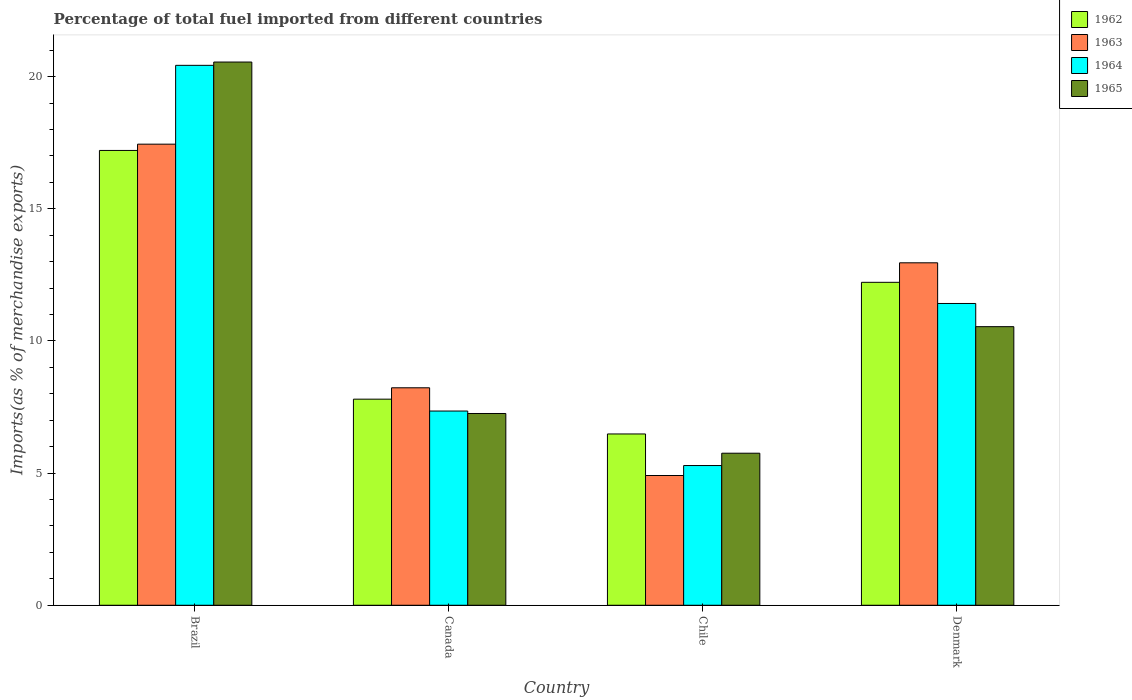How many different coloured bars are there?
Keep it short and to the point. 4. How many groups of bars are there?
Ensure brevity in your answer.  4. Are the number of bars per tick equal to the number of legend labels?
Keep it short and to the point. Yes. Are the number of bars on each tick of the X-axis equal?
Make the answer very short. Yes. How many bars are there on the 4th tick from the right?
Offer a terse response. 4. What is the percentage of imports to different countries in 1962 in Denmark?
Offer a very short reply. 12.22. Across all countries, what is the maximum percentage of imports to different countries in 1965?
Provide a succinct answer. 20.55. Across all countries, what is the minimum percentage of imports to different countries in 1964?
Keep it short and to the point. 5.29. In which country was the percentage of imports to different countries in 1964 maximum?
Your answer should be compact. Brazil. In which country was the percentage of imports to different countries in 1963 minimum?
Ensure brevity in your answer.  Chile. What is the total percentage of imports to different countries in 1965 in the graph?
Your answer should be compact. 44.11. What is the difference between the percentage of imports to different countries in 1965 in Canada and that in Denmark?
Provide a succinct answer. -3.29. What is the difference between the percentage of imports to different countries in 1963 in Chile and the percentage of imports to different countries in 1964 in Denmark?
Give a very brief answer. -6.51. What is the average percentage of imports to different countries in 1965 per country?
Offer a very short reply. 11.03. What is the difference between the percentage of imports to different countries of/in 1965 and percentage of imports to different countries of/in 1962 in Chile?
Provide a short and direct response. -0.73. What is the ratio of the percentage of imports to different countries in 1962 in Canada to that in Denmark?
Provide a short and direct response. 0.64. Is the difference between the percentage of imports to different countries in 1965 in Brazil and Canada greater than the difference between the percentage of imports to different countries in 1962 in Brazil and Canada?
Provide a succinct answer. Yes. What is the difference between the highest and the second highest percentage of imports to different countries in 1963?
Your answer should be compact. -9.22. What is the difference between the highest and the lowest percentage of imports to different countries in 1962?
Your answer should be very brief. 10.73. In how many countries, is the percentage of imports to different countries in 1962 greater than the average percentage of imports to different countries in 1962 taken over all countries?
Provide a succinct answer. 2. Is the sum of the percentage of imports to different countries in 1964 in Brazil and Denmark greater than the maximum percentage of imports to different countries in 1963 across all countries?
Ensure brevity in your answer.  Yes. What does the 1st bar from the right in Brazil represents?
Keep it short and to the point. 1965. Is it the case that in every country, the sum of the percentage of imports to different countries in 1964 and percentage of imports to different countries in 1965 is greater than the percentage of imports to different countries in 1962?
Ensure brevity in your answer.  Yes. Does the graph contain grids?
Your response must be concise. No. How many legend labels are there?
Your answer should be compact. 4. How are the legend labels stacked?
Offer a terse response. Vertical. What is the title of the graph?
Provide a succinct answer. Percentage of total fuel imported from different countries. Does "1983" appear as one of the legend labels in the graph?
Offer a very short reply. No. What is the label or title of the Y-axis?
Offer a terse response. Imports(as % of merchandise exports). What is the Imports(as % of merchandise exports) in 1962 in Brazil?
Your answer should be compact. 17.21. What is the Imports(as % of merchandise exports) in 1963 in Brazil?
Ensure brevity in your answer.  17.45. What is the Imports(as % of merchandise exports) of 1964 in Brazil?
Give a very brief answer. 20.43. What is the Imports(as % of merchandise exports) in 1965 in Brazil?
Ensure brevity in your answer.  20.55. What is the Imports(as % of merchandise exports) of 1962 in Canada?
Offer a very short reply. 7.8. What is the Imports(as % of merchandise exports) of 1963 in Canada?
Make the answer very short. 8.23. What is the Imports(as % of merchandise exports) in 1964 in Canada?
Ensure brevity in your answer.  7.35. What is the Imports(as % of merchandise exports) in 1965 in Canada?
Provide a succinct answer. 7.26. What is the Imports(as % of merchandise exports) in 1962 in Chile?
Keep it short and to the point. 6.48. What is the Imports(as % of merchandise exports) of 1963 in Chile?
Your answer should be very brief. 4.91. What is the Imports(as % of merchandise exports) in 1964 in Chile?
Your response must be concise. 5.29. What is the Imports(as % of merchandise exports) in 1965 in Chile?
Keep it short and to the point. 5.75. What is the Imports(as % of merchandise exports) of 1962 in Denmark?
Your answer should be very brief. 12.22. What is the Imports(as % of merchandise exports) of 1963 in Denmark?
Make the answer very short. 12.96. What is the Imports(as % of merchandise exports) in 1964 in Denmark?
Your answer should be compact. 11.42. What is the Imports(as % of merchandise exports) of 1965 in Denmark?
Provide a short and direct response. 10.54. Across all countries, what is the maximum Imports(as % of merchandise exports) in 1962?
Keep it short and to the point. 17.21. Across all countries, what is the maximum Imports(as % of merchandise exports) of 1963?
Your answer should be very brief. 17.45. Across all countries, what is the maximum Imports(as % of merchandise exports) in 1964?
Make the answer very short. 20.43. Across all countries, what is the maximum Imports(as % of merchandise exports) in 1965?
Offer a very short reply. 20.55. Across all countries, what is the minimum Imports(as % of merchandise exports) of 1962?
Your answer should be compact. 6.48. Across all countries, what is the minimum Imports(as % of merchandise exports) of 1963?
Your answer should be very brief. 4.91. Across all countries, what is the minimum Imports(as % of merchandise exports) of 1964?
Make the answer very short. 5.29. Across all countries, what is the minimum Imports(as % of merchandise exports) in 1965?
Ensure brevity in your answer.  5.75. What is the total Imports(as % of merchandise exports) of 1962 in the graph?
Make the answer very short. 43.71. What is the total Imports(as % of merchandise exports) of 1963 in the graph?
Provide a succinct answer. 43.54. What is the total Imports(as % of merchandise exports) in 1964 in the graph?
Provide a succinct answer. 44.48. What is the total Imports(as % of merchandise exports) of 1965 in the graph?
Ensure brevity in your answer.  44.1. What is the difference between the Imports(as % of merchandise exports) of 1962 in Brazil and that in Canada?
Keep it short and to the point. 9.41. What is the difference between the Imports(as % of merchandise exports) in 1963 in Brazil and that in Canada?
Give a very brief answer. 9.22. What is the difference between the Imports(as % of merchandise exports) in 1964 in Brazil and that in Canada?
Your response must be concise. 13.08. What is the difference between the Imports(as % of merchandise exports) of 1965 in Brazil and that in Canada?
Make the answer very short. 13.3. What is the difference between the Imports(as % of merchandise exports) in 1962 in Brazil and that in Chile?
Give a very brief answer. 10.73. What is the difference between the Imports(as % of merchandise exports) of 1963 in Brazil and that in Chile?
Keep it short and to the point. 12.54. What is the difference between the Imports(as % of merchandise exports) in 1964 in Brazil and that in Chile?
Offer a terse response. 15.14. What is the difference between the Imports(as % of merchandise exports) of 1965 in Brazil and that in Chile?
Your answer should be compact. 14.8. What is the difference between the Imports(as % of merchandise exports) of 1962 in Brazil and that in Denmark?
Offer a terse response. 4.99. What is the difference between the Imports(as % of merchandise exports) in 1963 in Brazil and that in Denmark?
Give a very brief answer. 4.49. What is the difference between the Imports(as % of merchandise exports) in 1964 in Brazil and that in Denmark?
Offer a terse response. 9.01. What is the difference between the Imports(as % of merchandise exports) of 1965 in Brazil and that in Denmark?
Offer a very short reply. 10.01. What is the difference between the Imports(as % of merchandise exports) of 1962 in Canada and that in Chile?
Offer a very short reply. 1.32. What is the difference between the Imports(as % of merchandise exports) in 1963 in Canada and that in Chile?
Your response must be concise. 3.32. What is the difference between the Imports(as % of merchandise exports) of 1964 in Canada and that in Chile?
Make the answer very short. 2.06. What is the difference between the Imports(as % of merchandise exports) of 1965 in Canada and that in Chile?
Provide a succinct answer. 1.5. What is the difference between the Imports(as % of merchandise exports) of 1962 in Canada and that in Denmark?
Your answer should be compact. -4.42. What is the difference between the Imports(as % of merchandise exports) in 1963 in Canada and that in Denmark?
Your answer should be very brief. -4.73. What is the difference between the Imports(as % of merchandise exports) in 1964 in Canada and that in Denmark?
Ensure brevity in your answer.  -4.07. What is the difference between the Imports(as % of merchandise exports) of 1965 in Canada and that in Denmark?
Keep it short and to the point. -3.29. What is the difference between the Imports(as % of merchandise exports) of 1962 in Chile and that in Denmark?
Provide a short and direct response. -5.74. What is the difference between the Imports(as % of merchandise exports) of 1963 in Chile and that in Denmark?
Your response must be concise. -8.05. What is the difference between the Imports(as % of merchandise exports) of 1964 in Chile and that in Denmark?
Make the answer very short. -6.13. What is the difference between the Imports(as % of merchandise exports) of 1965 in Chile and that in Denmark?
Give a very brief answer. -4.79. What is the difference between the Imports(as % of merchandise exports) of 1962 in Brazil and the Imports(as % of merchandise exports) of 1963 in Canada?
Keep it short and to the point. 8.98. What is the difference between the Imports(as % of merchandise exports) of 1962 in Brazil and the Imports(as % of merchandise exports) of 1964 in Canada?
Your answer should be very brief. 9.86. What is the difference between the Imports(as % of merchandise exports) of 1962 in Brazil and the Imports(as % of merchandise exports) of 1965 in Canada?
Give a very brief answer. 9.95. What is the difference between the Imports(as % of merchandise exports) in 1963 in Brazil and the Imports(as % of merchandise exports) in 1964 in Canada?
Offer a very short reply. 10.1. What is the difference between the Imports(as % of merchandise exports) in 1963 in Brazil and the Imports(as % of merchandise exports) in 1965 in Canada?
Offer a terse response. 10.19. What is the difference between the Imports(as % of merchandise exports) of 1964 in Brazil and the Imports(as % of merchandise exports) of 1965 in Canada?
Offer a very short reply. 13.17. What is the difference between the Imports(as % of merchandise exports) of 1962 in Brazil and the Imports(as % of merchandise exports) of 1963 in Chile?
Offer a terse response. 12.3. What is the difference between the Imports(as % of merchandise exports) in 1962 in Brazil and the Imports(as % of merchandise exports) in 1964 in Chile?
Provide a succinct answer. 11.92. What is the difference between the Imports(as % of merchandise exports) of 1962 in Brazil and the Imports(as % of merchandise exports) of 1965 in Chile?
Keep it short and to the point. 11.46. What is the difference between the Imports(as % of merchandise exports) in 1963 in Brazil and the Imports(as % of merchandise exports) in 1964 in Chile?
Ensure brevity in your answer.  12.16. What is the difference between the Imports(as % of merchandise exports) of 1963 in Brazil and the Imports(as % of merchandise exports) of 1965 in Chile?
Offer a terse response. 11.69. What is the difference between the Imports(as % of merchandise exports) in 1964 in Brazil and the Imports(as % of merchandise exports) in 1965 in Chile?
Provide a short and direct response. 14.68. What is the difference between the Imports(as % of merchandise exports) of 1962 in Brazil and the Imports(as % of merchandise exports) of 1963 in Denmark?
Provide a short and direct response. 4.25. What is the difference between the Imports(as % of merchandise exports) in 1962 in Brazil and the Imports(as % of merchandise exports) in 1964 in Denmark?
Offer a very short reply. 5.79. What is the difference between the Imports(as % of merchandise exports) of 1962 in Brazil and the Imports(as % of merchandise exports) of 1965 in Denmark?
Offer a very short reply. 6.67. What is the difference between the Imports(as % of merchandise exports) in 1963 in Brazil and the Imports(as % of merchandise exports) in 1964 in Denmark?
Provide a succinct answer. 6.03. What is the difference between the Imports(as % of merchandise exports) in 1963 in Brazil and the Imports(as % of merchandise exports) in 1965 in Denmark?
Provide a short and direct response. 6.91. What is the difference between the Imports(as % of merchandise exports) of 1964 in Brazil and the Imports(as % of merchandise exports) of 1965 in Denmark?
Provide a succinct answer. 9.89. What is the difference between the Imports(as % of merchandise exports) of 1962 in Canada and the Imports(as % of merchandise exports) of 1963 in Chile?
Your answer should be compact. 2.89. What is the difference between the Imports(as % of merchandise exports) of 1962 in Canada and the Imports(as % of merchandise exports) of 1964 in Chile?
Provide a short and direct response. 2.51. What is the difference between the Imports(as % of merchandise exports) in 1962 in Canada and the Imports(as % of merchandise exports) in 1965 in Chile?
Your response must be concise. 2.04. What is the difference between the Imports(as % of merchandise exports) in 1963 in Canada and the Imports(as % of merchandise exports) in 1964 in Chile?
Offer a very short reply. 2.94. What is the difference between the Imports(as % of merchandise exports) of 1963 in Canada and the Imports(as % of merchandise exports) of 1965 in Chile?
Your answer should be very brief. 2.48. What is the difference between the Imports(as % of merchandise exports) in 1964 in Canada and the Imports(as % of merchandise exports) in 1965 in Chile?
Your answer should be very brief. 1.6. What is the difference between the Imports(as % of merchandise exports) in 1962 in Canada and the Imports(as % of merchandise exports) in 1963 in Denmark?
Your answer should be compact. -5.16. What is the difference between the Imports(as % of merchandise exports) in 1962 in Canada and the Imports(as % of merchandise exports) in 1964 in Denmark?
Your answer should be very brief. -3.62. What is the difference between the Imports(as % of merchandise exports) in 1962 in Canada and the Imports(as % of merchandise exports) in 1965 in Denmark?
Make the answer very short. -2.74. What is the difference between the Imports(as % of merchandise exports) of 1963 in Canada and the Imports(as % of merchandise exports) of 1964 in Denmark?
Offer a terse response. -3.19. What is the difference between the Imports(as % of merchandise exports) in 1963 in Canada and the Imports(as % of merchandise exports) in 1965 in Denmark?
Provide a succinct answer. -2.31. What is the difference between the Imports(as % of merchandise exports) of 1964 in Canada and the Imports(as % of merchandise exports) of 1965 in Denmark?
Make the answer very short. -3.19. What is the difference between the Imports(as % of merchandise exports) of 1962 in Chile and the Imports(as % of merchandise exports) of 1963 in Denmark?
Offer a terse response. -6.48. What is the difference between the Imports(as % of merchandise exports) in 1962 in Chile and the Imports(as % of merchandise exports) in 1964 in Denmark?
Provide a short and direct response. -4.94. What is the difference between the Imports(as % of merchandise exports) in 1962 in Chile and the Imports(as % of merchandise exports) in 1965 in Denmark?
Your answer should be compact. -4.06. What is the difference between the Imports(as % of merchandise exports) of 1963 in Chile and the Imports(as % of merchandise exports) of 1964 in Denmark?
Ensure brevity in your answer.  -6.51. What is the difference between the Imports(as % of merchandise exports) in 1963 in Chile and the Imports(as % of merchandise exports) in 1965 in Denmark?
Provide a short and direct response. -5.63. What is the difference between the Imports(as % of merchandise exports) in 1964 in Chile and the Imports(as % of merchandise exports) in 1965 in Denmark?
Provide a short and direct response. -5.25. What is the average Imports(as % of merchandise exports) of 1962 per country?
Make the answer very short. 10.93. What is the average Imports(as % of merchandise exports) in 1963 per country?
Offer a very short reply. 10.89. What is the average Imports(as % of merchandise exports) in 1964 per country?
Your answer should be compact. 11.12. What is the average Imports(as % of merchandise exports) in 1965 per country?
Give a very brief answer. 11.03. What is the difference between the Imports(as % of merchandise exports) of 1962 and Imports(as % of merchandise exports) of 1963 in Brazil?
Offer a very short reply. -0.24. What is the difference between the Imports(as % of merchandise exports) of 1962 and Imports(as % of merchandise exports) of 1964 in Brazil?
Provide a short and direct response. -3.22. What is the difference between the Imports(as % of merchandise exports) in 1962 and Imports(as % of merchandise exports) in 1965 in Brazil?
Make the answer very short. -3.35. What is the difference between the Imports(as % of merchandise exports) of 1963 and Imports(as % of merchandise exports) of 1964 in Brazil?
Your response must be concise. -2.98. What is the difference between the Imports(as % of merchandise exports) in 1963 and Imports(as % of merchandise exports) in 1965 in Brazil?
Your answer should be very brief. -3.11. What is the difference between the Imports(as % of merchandise exports) of 1964 and Imports(as % of merchandise exports) of 1965 in Brazil?
Give a very brief answer. -0.12. What is the difference between the Imports(as % of merchandise exports) in 1962 and Imports(as % of merchandise exports) in 1963 in Canada?
Make the answer very short. -0.43. What is the difference between the Imports(as % of merchandise exports) in 1962 and Imports(as % of merchandise exports) in 1964 in Canada?
Provide a succinct answer. 0.45. What is the difference between the Imports(as % of merchandise exports) of 1962 and Imports(as % of merchandise exports) of 1965 in Canada?
Your response must be concise. 0.54. What is the difference between the Imports(as % of merchandise exports) in 1963 and Imports(as % of merchandise exports) in 1964 in Canada?
Provide a succinct answer. 0.88. What is the difference between the Imports(as % of merchandise exports) in 1963 and Imports(as % of merchandise exports) in 1965 in Canada?
Your response must be concise. 0.97. What is the difference between the Imports(as % of merchandise exports) of 1964 and Imports(as % of merchandise exports) of 1965 in Canada?
Offer a very short reply. 0.09. What is the difference between the Imports(as % of merchandise exports) in 1962 and Imports(as % of merchandise exports) in 1963 in Chile?
Offer a very short reply. 1.57. What is the difference between the Imports(as % of merchandise exports) in 1962 and Imports(as % of merchandise exports) in 1964 in Chile?
Give a very brief answer. 1.19. What is the difference between the Imports(as % of merchandise exports) of 1962 and Imports(as % of merchandise exports) of 1965 in Chile?
Keep it short and to the point. 0.73. What is the difference between the Imports(as % of merchandise exports) of 1963 and Imports(as % of merchandise exports) of 1964 in Chile?
Your response must be concise. -0.38. What is the difference between the Imports(as % of merchandise exports) of 1963 and Imports(as % of merchandise exports) of 1965 in Chile?
Offer a very short reply. -0.84. What is the difference between the Imports(as % of merchandise exports) of 1964 and Imports(as % of merchandise exports) of 1965 in Chile?
Give a very brief answer. -0.47. What is the difference between the Imports(as % of merchandise exports) in 1962 and Imports(as % of merchandise exports) in 1963 in Denmark?
Provide a short and direct response. -0.74. What is the difference between the Imports(as % of merchandise exports) of 1962 and Imports(as % of merchandise exports) of 1964 in Denmark?
Offer a very short reply. 0.8. What is the difference between the Imports(as % of merchandise exports) of 1962 and Imports(as % of merchandise exports) of 1965 in Denmark?
Your response must be concise. 1.68. What is the difference between the Imports(as % of merchandise exports) of 1963 and Imports(as % of merchandise exports) of 1964 in Denmark?
Your response must be concise. 1.54. What is the difference between the Imports(as % of merchandise exports) in 1963 and Imports(as % of merchandise exports) in 1965 in Denmark?
Give a very brief answer. 2.42. What is the difference between the Imports(as % of merchandise exports) in 1964 and Imports(as % of merchandise exports) in 1965 in Denmark?
Offer a very short reply. 0.88. What is the ratio of the Imports(as % of merchandise exports) of 1962 in Brazil to that in Canada?
Ensure brevity in your answer.  2.21. What is the ratio of the Imports(as % of merchandise exports) of 1963 in Brazil to that in Canada?
Offer a very short reply. 2.12. What is the ratio of the Imports(as % of merchandise exports) in 1964 in Brazil to that in Canada?
Your response must be concise. 2.78. What is the ratio of the Imports(as % of merchandise exports) of 1965 in Brazil to that in Canada?
Give a very brief answer. 2.83. What is the ratio of the Imports(as % of merchandise exports) of 1962 in Brazil to that in Chile?
Your answer should be compact. 2.65. What is the ratio of the Imports(as % of merchandise exports) of 1963 in Brazil to that in Chile?
Provide a succinct answer. 3.55. What is the ratio of the Imports(as % of merchandise exports) in 1964 in Brazil to that in Chile?
Your answer should be compact. 3.86. What is the ratio of the Imports(as % of merchandise exports) of 1965 in Brazil to that in Chile?
Your response must be concise. 3.57. What is the ratio of the Imports(as % of merchandise exports) in 1962 in Brazil to that in Denmark?
Provide a succinct answer. 1.41. What is the ratio of the Imports(as % of merchandise exports) of 1963 in Brazil to that in Denmark?
Offer a very short reply. 1.35. What is the ratio of the Imports(as % of merchandise exports) in 1964 in Brazil to that in Denmark?
Make the answer very short. 1.79. What is the ratio of the Imports(as % of merchandise exports) in 1965 in Brazil to that in Denmark?
Provide a short and direct response. 1.95. What is the ratio of the Imports(as % of merchandise exports) of 1962 in Canada to that in Chile?
Give a very brief answer. 1.2. What is the ratio of the Imports(as % of merchandise exports) in 1963 in Canada to that in Chile?
Offer a terse response. 1.68. What is the ratio of the Imports(as % of merchandise exports) of 1964 in Canada to that in Chile?
Your response must be concise. 1.39. What is the ratio of the Imports(as % of merchandise exports) of 1965 in Canada to that in Chile?
Your answer should be compact. 1.26. What is the ratio of the Imports(as % of merchandise exports) of 1962 in Canada to that in Denmark?
Provide a short and direct response. 0.64. What is the ratio of the Imports(as % of merchandise exports) of 1963 in Canada to that in Denmark?
Provide a short and direct response. 0.64. What is the ratio of the Imports(as % of merchandise exports) in 1964 in Canada to that in Denmark?
Keep it short and to the point. 0.64. What is the ratio of the Imports(as % of merchandise exports) in 1965 in Canada to that in Denmark?
Provide a short and direct response. 0.69. What is the ratio of the Imports(as % of merchandise exports) in 1962 in Chile to that in Denmark?
Make the answer very short. 0.53. What is the ratio of the Imports(as % of merchandise exports) of 1963 in Chile to that in Denmark?
Your answer should be very brief. 0.38. What is the ratio of the Imports(as % of merchandise exports) of 1964 in Chile to that in Denmark?
Your answer should be compact. 0.46. What is the ratio of the Imports(as % of merchandise exports) in 1965 in Chile to that in Denmark?
Your response must be concise. 0.55. What is the difference between the highest and the second highest Imports(as % of merchandise exports) of 1962?
Your answer should be very brief. 4.99. What is the difference between the highest and the second highest Imports(as % of merchandise exports) in 1963?
Make the answer very short. 4.49. What is the difference between the highest and the second highest Imports(as % of merchandise exports) of 1964?
Offer a terse response. 9.01. What is the difference between the highest and the second highest Imports(as % of merchandise exports) in 1965?
Make the answer very short. 10.01. What is the difference between the highest and the lowest Imports(as % of merchandise exports) in 1962?
Provide a succinct answer. 10.73. What is the difference between the highest and the lowest Imports(as % of merchandise exports) of 1963?
Make the answer very short. 12.54. What is the difference between the highest and the lowest Imports(as % of merchandise exports) of 1964?
Provide a succinct answer. 15.14. What is the difference between the highest and the lowest Imports(as % of merchandise exports) of 1965?
Make the answer very short. 14.8. 